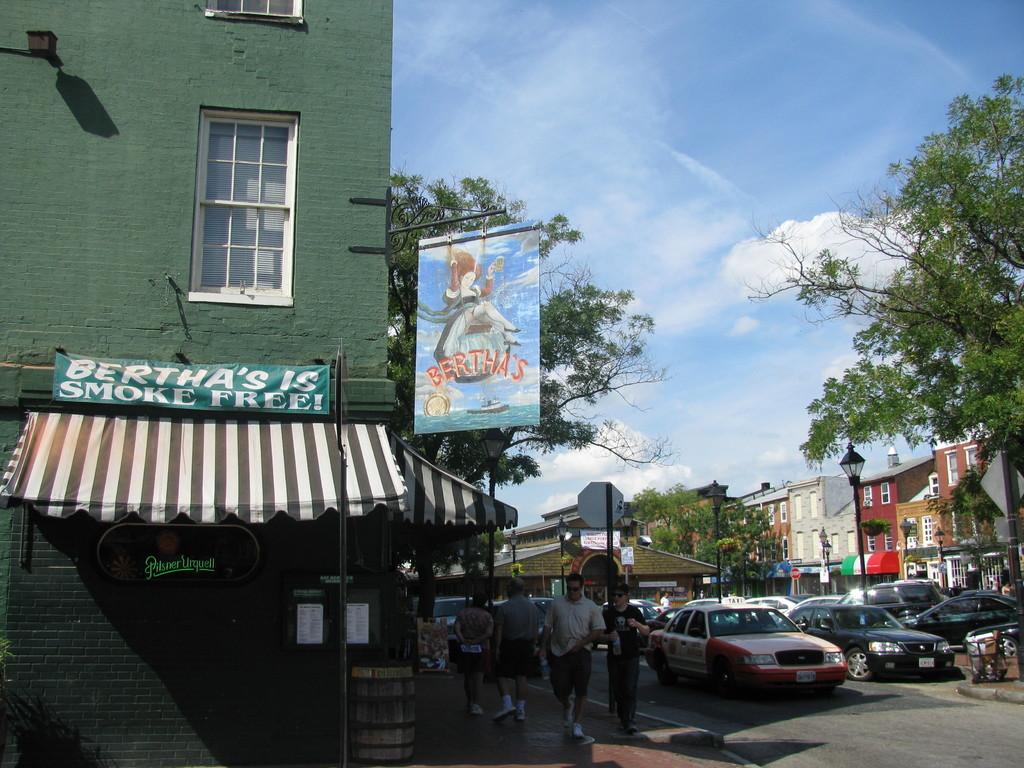What is bertha's free of?
Ensure brevity in your answer.  Smoke. What is on the fabric sign hanging up?
Offer a terse response. Bertha's. 